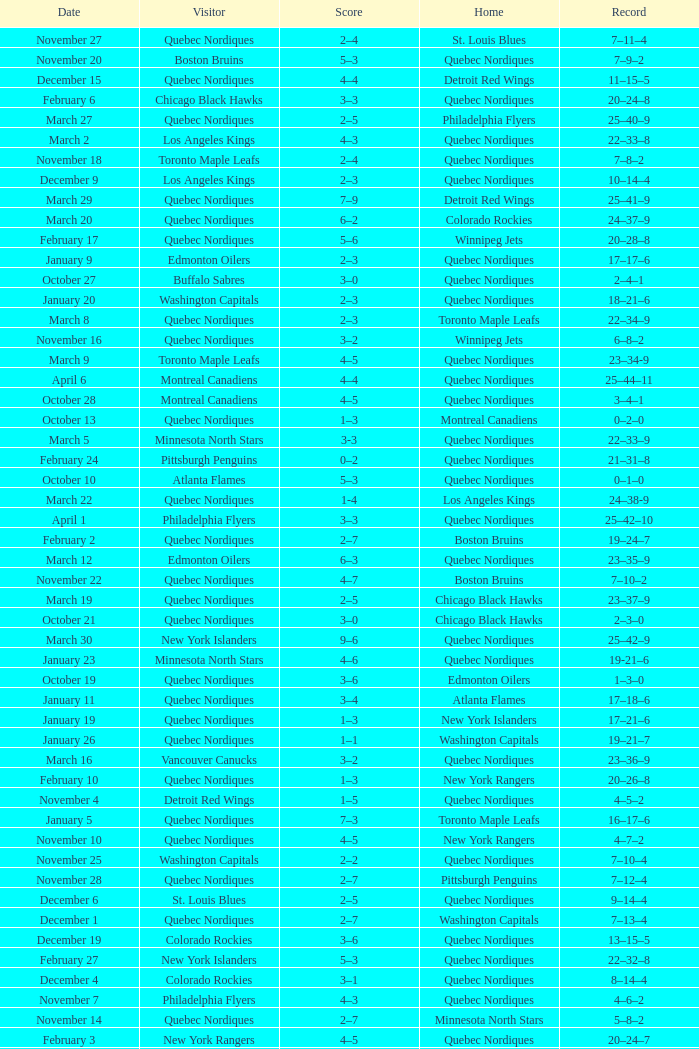Which Record has a Home of edmonton oilers, and a Score of 3–6? 1–3–0. 